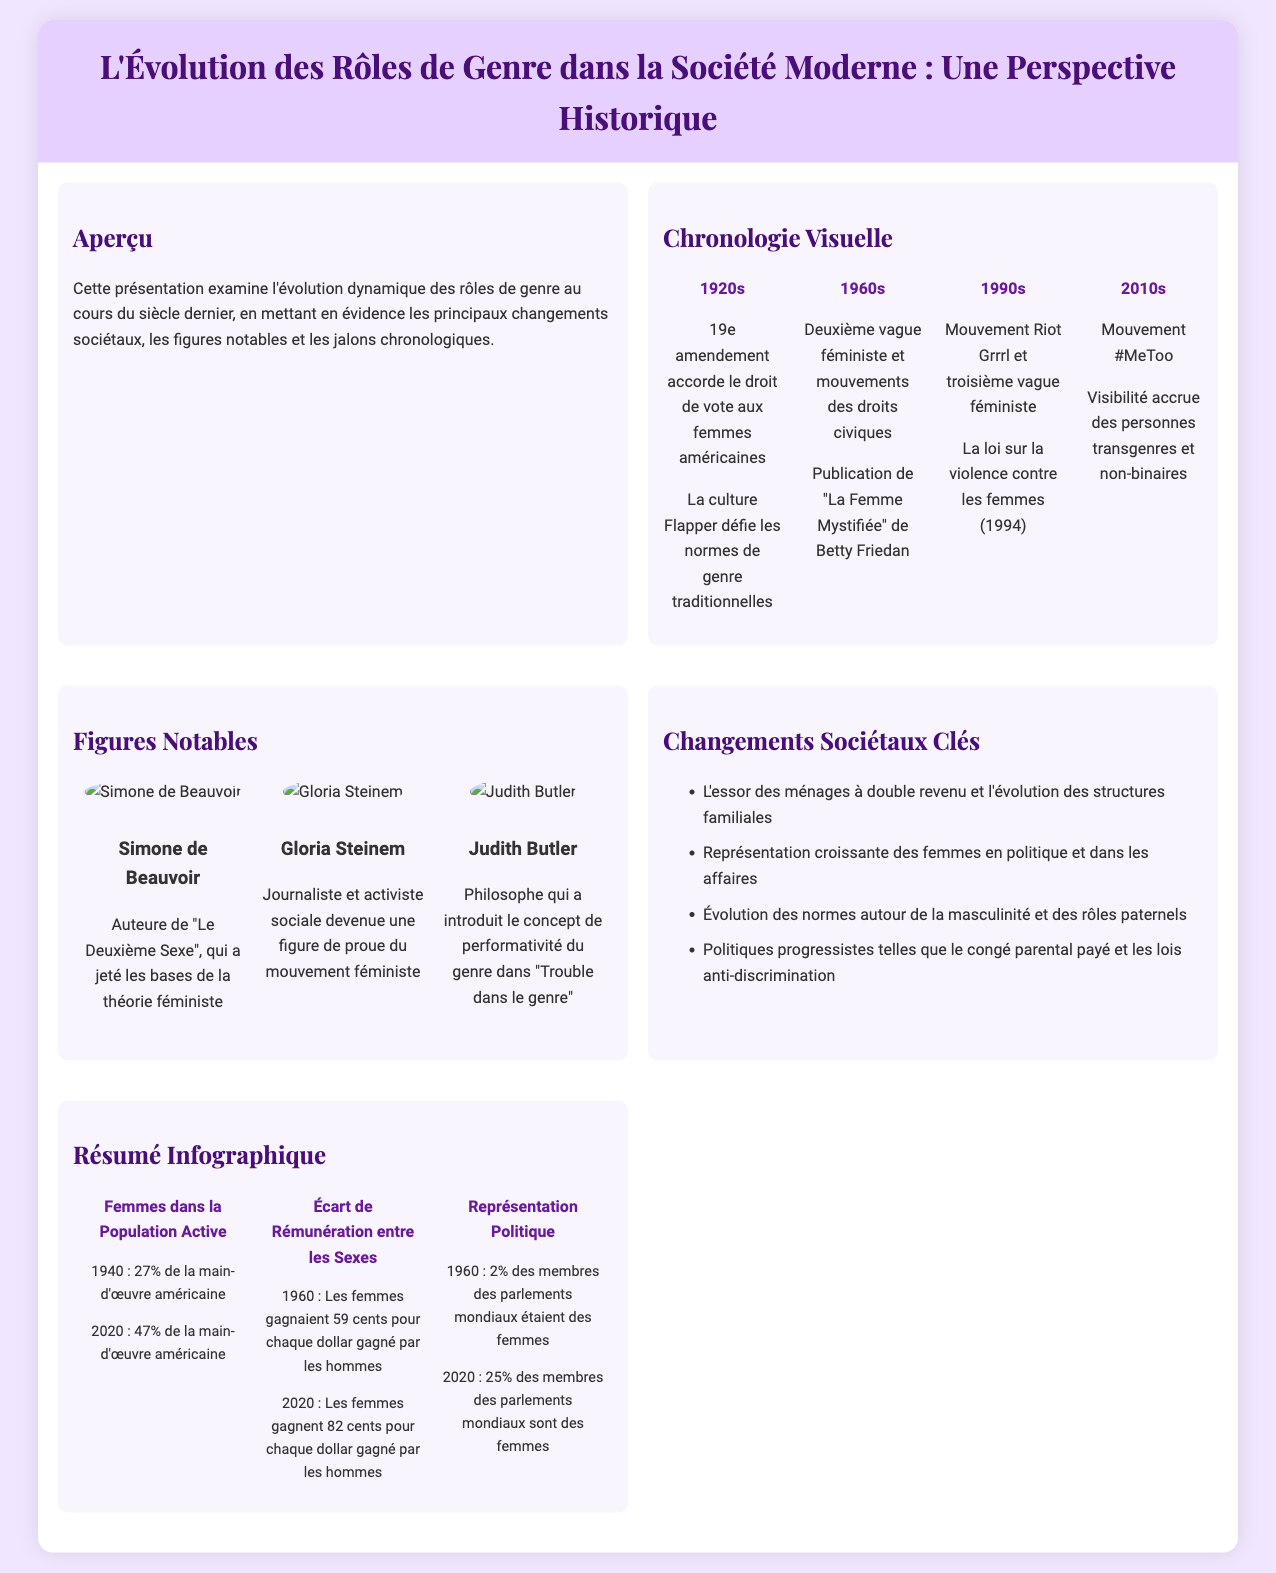Quelle décennie a vu l'adoption du 19e amendement ? Le 19e amendement a été adopté dans les années 1920, une époque marquée par des changements significatifs en matière de droits des femmes.
Answer: années 1920 Quel est le titre du livre de Betty Friedan publié dans les années 1960 ? Le livre publié par Betty Friedan dans les années 1960 est intitulé "La Femme Mystifiée".
Answer: La Femme Mystifiée Quel pourcentage des membres des parlements mondiaux étaient des femmes en 1960 ? En 1960, seulement 2% des membres des parlements mondiaux étaient des femmes, selon les données présentées.
Answer: 2% Qui est l'auteure de "Le Deuxième Sexe" ? Simone de Beauvoir est l'auteure de "Le Deuxième Sexe", un ouvrage fondamental de la théorie féministe.
Answer: Simone de Beauvoir Quel mouvement important a émergé dans les années 2010 ? Le mouvement #MeToo est un mouvement culturel important qui a émergé dans les années 2010, à promouvoir l'égalité des sexes et à sensibiliser aux abus.
Answer: #MeToo Quel était le pourcentage de femmes dans la population active américaine en 1940 ? En 1940, le pourcentage de femmes dans la population active américaine était de 27%.
Answer: 27% Quelle figure a introduit le concept de performativité du genre ? Judith Butler a introduit le concept de performativité du genre, important dans la théorie des genres.
Answer: Judith Butler Quel événement a eu lieu dans les années 1990 concernant la violence contre les femmes ? La loi sur la violence contre les femmes a été adoptée en 1994, marquant un jalon dans la lutte pour les droits des femmes.
Answer: 1994 Quels changements quantitatifs des rôles de genre sont observés avec le temps ? L'infographie montre une progression de la représentation des femmes dans divers domaines, notamment dans la population active et les parlements.
Answer: Progression 